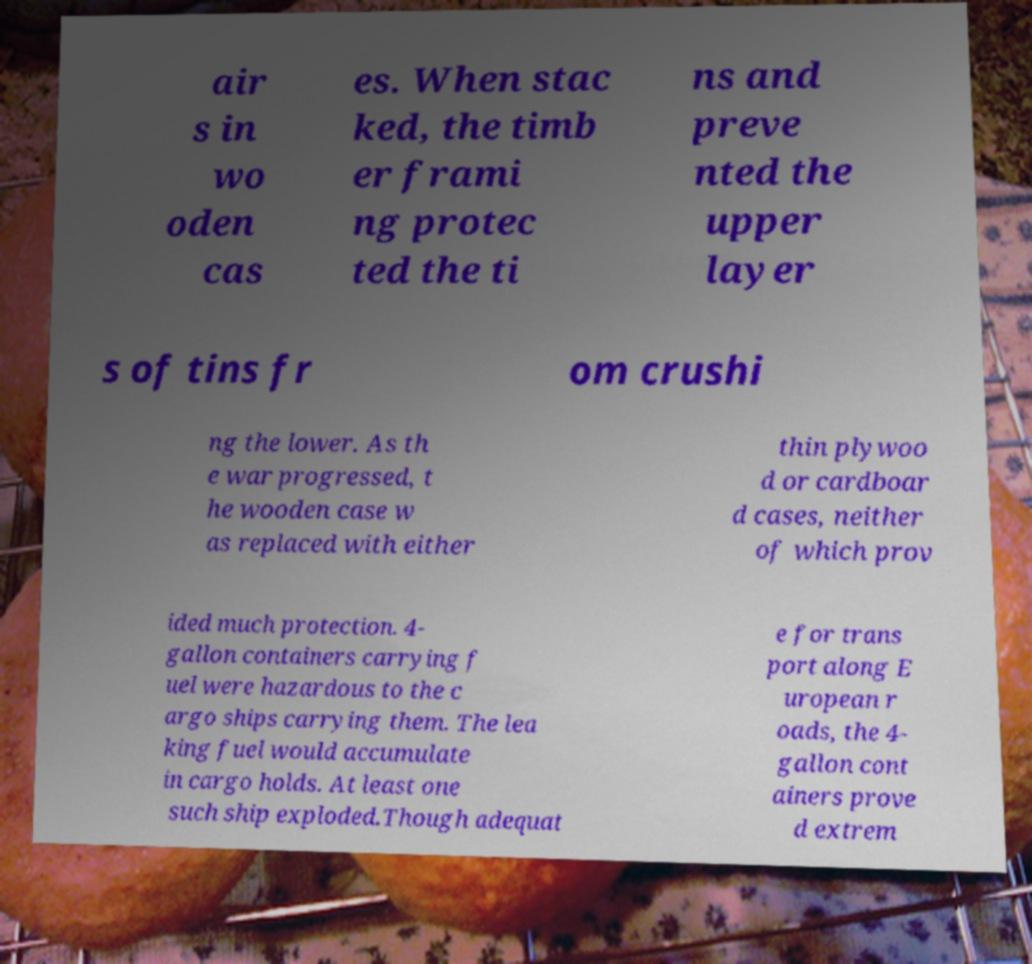Could you extract and type out the text from this image? air s in wo oden cas es. When stac ked, the timb er frami ng protec ted the ti ns and preve nted the upper layer s of tins fr om crushi ng the lower. As th e war progressed, t he wooden case w as replaced with either thin plywoo d or cardboar d cases, neither of which prov ided much protection. 4- gallon containers carrying f uel were hazardous to the c argo ships carrying them. The lea king fuel would accumulate in cargo holds. At least one such ship exploded.Though adequat e for trans port along E uropean r oads, the 4- gallon cont ainers prove d extrem 